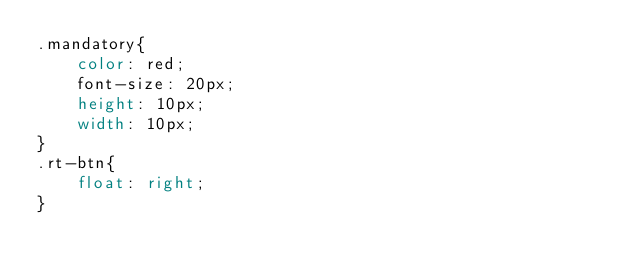Convert code to text. <code><loc_0><loc_0><loc_500><loc_500><_CSS_>.mandatory{
    color: red;
    font-size: 20px;
    height: 10px;
    width: 10px;
}
.rt-btn{
    float: right;
}
</code> 